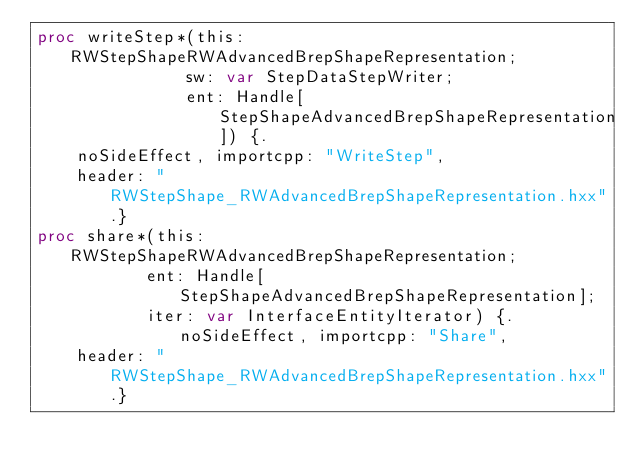Convert code to text. <code><loc_0><loc_0><loc_500><loc_500><_Nim_>proc writeStep*(this: RWStepShapeRWAdvancedBrepShapeRepresentation;
               sw: var StepDataStepWriter;
               ent: Handle[StepShapeAdvancedBrepShapeRepresentation]) {.
    noSideEffect, importcpp: "WriteStep",
    header: "RWStepShape_RWAdvancedBrepShapeRepresentation.hxx".}
proc share*(this: RWStepShapeRWAdvancedBrepShapeRepresentation;
           ent: Handle[StepShapeAdvancedBrepShapeRepresentation];
           iter: var InterfaceEntityIterator) {.noSideEffect, importcpp: "Share",
    header: "RWStepShape_RWAdvancedBrepShapeRepresentation.hxx".}

























</code> 